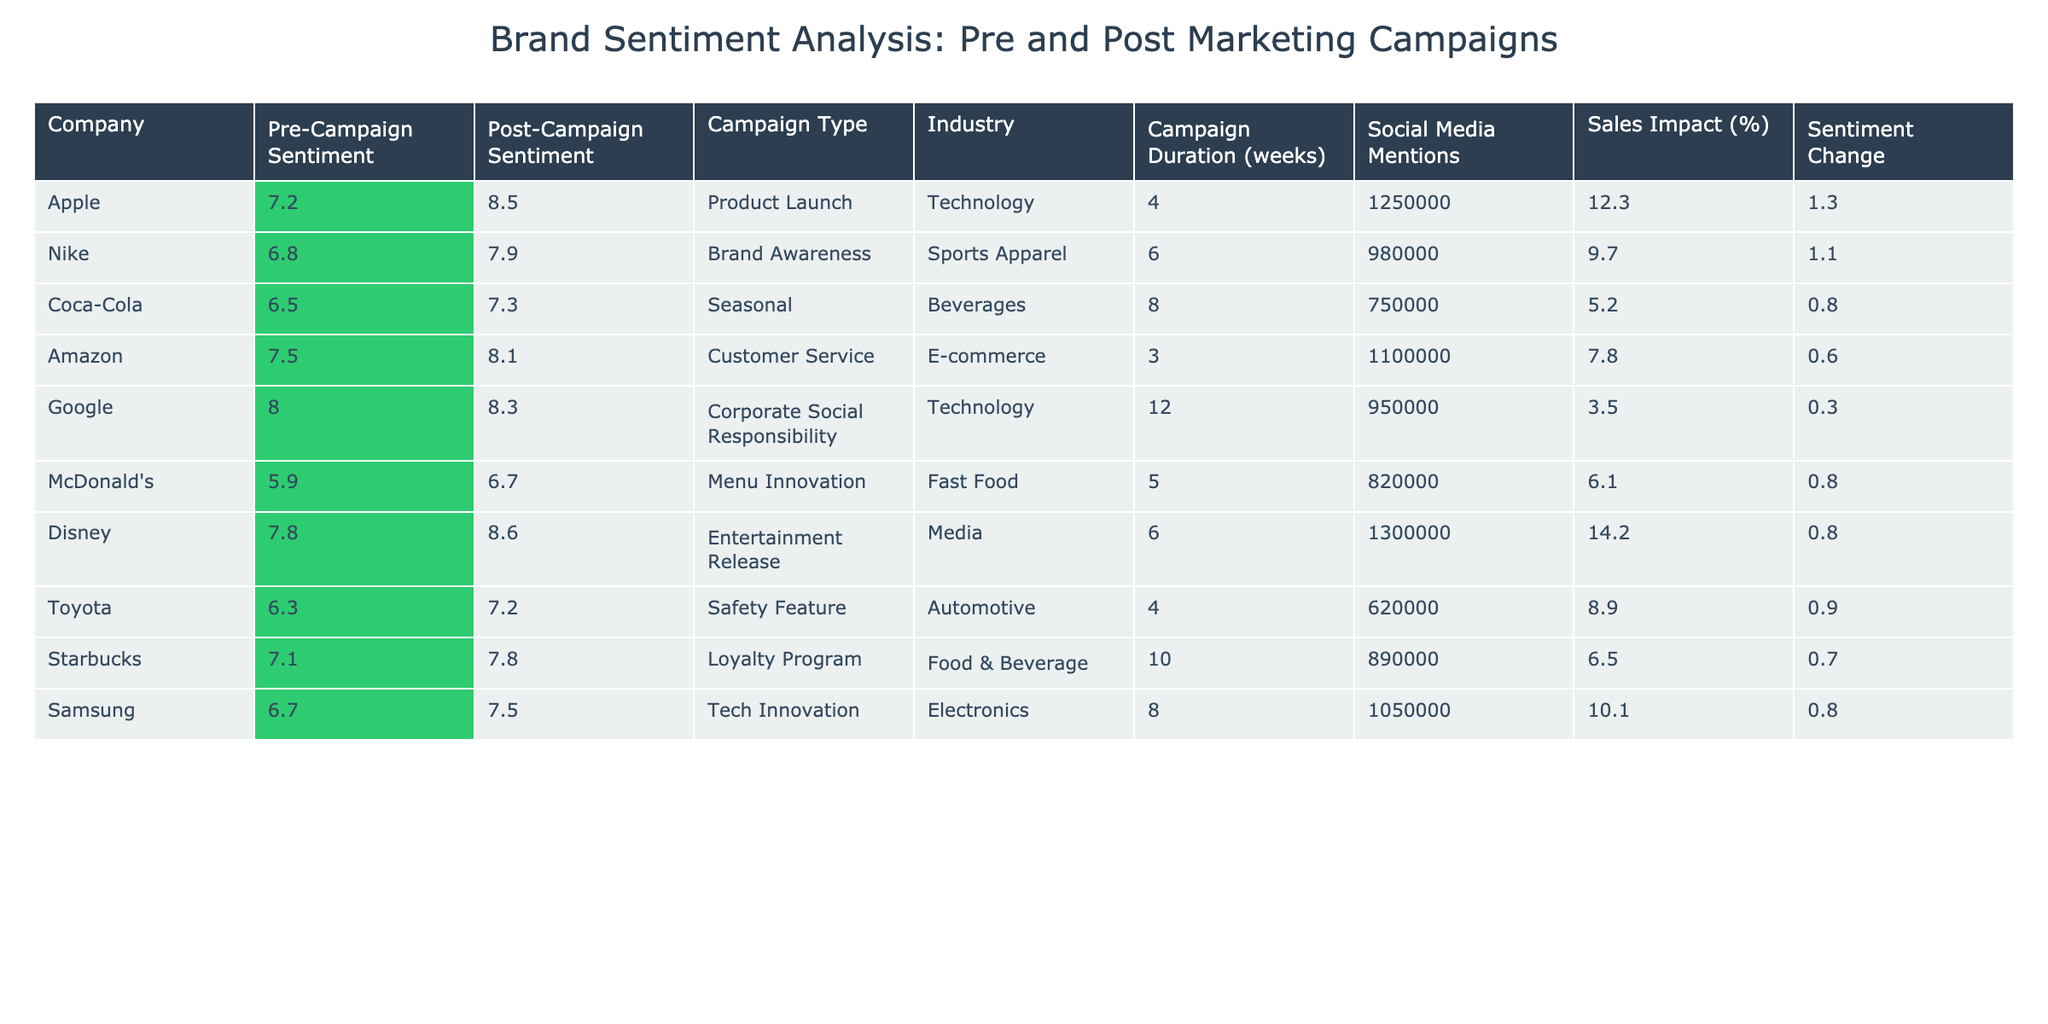What is the post-campaign sentiment score for Apple? The table shows the "Post-Campaign Sentiment" score for Apple as 8.5.
Answer: 8.5 What is the sentiment change for Coca-Cola? The sentiment change is calculated by subtracting the "Pre-Campaign Sentiment" (6.5) from the "Post-Campaign Sentiment" (7.3), which results in 7.3 - 6.5 = 0.8.
Answer: 0.8 Which company had the highest post-campaign sentiment score? Looking at the "Post-Campaign Sentiment" scores, Disney scored the highest at 8.6.
Answer: Disney Did Nike have a positive sentiment change after its marketing campaign? The sentiment change for Nike is 7.9 (post) - 6.8 (pre) = 1.1, which is positive.
Answer: Yes Which company in the Technology industry had the largest sentiment increase? For Technology, Apple increased from 7.2 to 8.5 (1.3 change) and Google from 8.0 to 8.3 (0.3 change). Therefore, Apple had the largest increase among Technology companies.
Answer: Apple What is the average sales impact percentage for the companies listed? The sales impact values are: 12.3, 9.7, 5.2, 7.8, 3.5, 6.1, 14.2, 8.9, 6.5, and 10.1. Summing these gives 83.2, and dividing by 10 gives an average of 8.32.
Answer: 8.32 Did any company in the Fast Food industry have a higher post-campaign sentiment score than 7? McDonald's had a post-campaign sentiment score of 6.7, which is not higher than 7. Thus, no company achieved that threshold in Fast Food.
Answer: No Which campaign type resulted in the highest sentiment change overall? The sentiment changes are: Apple (1.3), Nike (1.1), Coca-Cola (0.8), Amazon (0.6), Google (0.3), McDonald’s (0.8), Disney (0.8), Toyota (0.9), Starbucks (0.7), and Samsung (0.8). The highest is from Apple with a sentiment change of 1.3.
Answer: Product Launch What was the campaign duration for the company with the most social media mentions? Apple had 1,250,000 social media mentions with a campaign duration of 4 weeks. However, Disney had more mentions at 1,300,000 and a duration of 6 weeks.
Answer: 6 weeks How does the sales impact of the campaign for Amazon compare to that of Coca-Cola? Amazon had a sales impact of 7.8%, while Coca-Cola had 5.2%. Therefore, Amazon's sales impact is higher than Coca-Cola's.
Answer: Amazon's impact is higher 